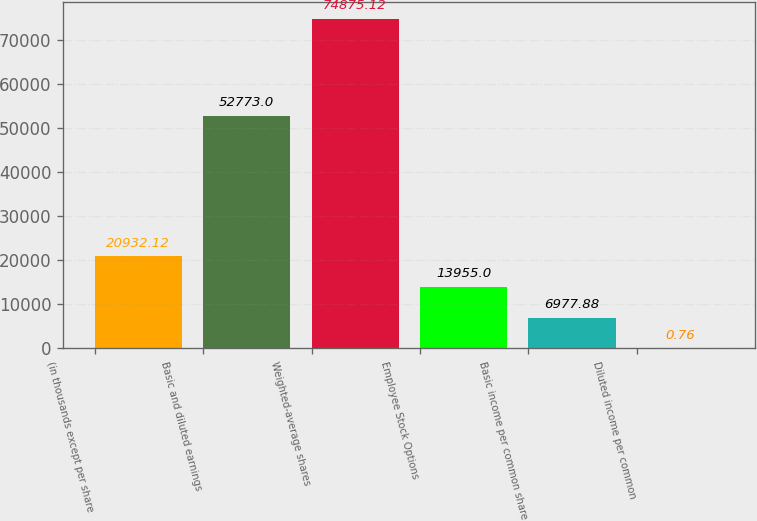<chart> <loc_0><loc_0><loc_500><loc_500><bar_chart><fcel>(in thousands except per share<fcel>Basic and diluted earnings<fcel>Weighted-average shares<fcel>Employee Stock Options<fcel>Basic income per common share<fcel>Diluted income per common<nl><fcel>20932.1<fcel>52773<fcel>74875.1<fcel>13955<fcel>6977.88<fcel>0.76<nl></chart> 